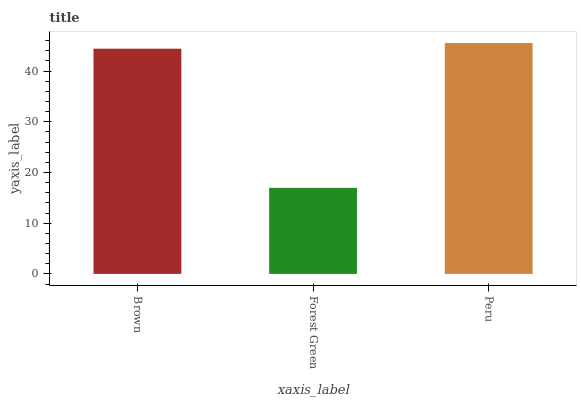Is Forest Green the minimum?
Answer yes or no. Yes. Is Peru the maximum?
Answer yes or no. Yes. Is Peru the minimum?
Answer yes or no. No. Is Forest Green the maximum?
Answer yes or no. No. Is Peru greater than Forest Green?
Answer yes or no. Yes. Is Forest Green less than Peru?
Answer yes or no. Yes. Is Forest Green greater than Peru?
Answer yes or no. No. Is Peru less than Forest Green?
Answer yes or no. No. Is Brown the high median?
Answer yes or no. Yes. Is Brown the low median?
Answer yes or no. Yes. Is Peru the high median?
Answer yes or no. No. Is Peru the low median?
Answer yes or no. No. 